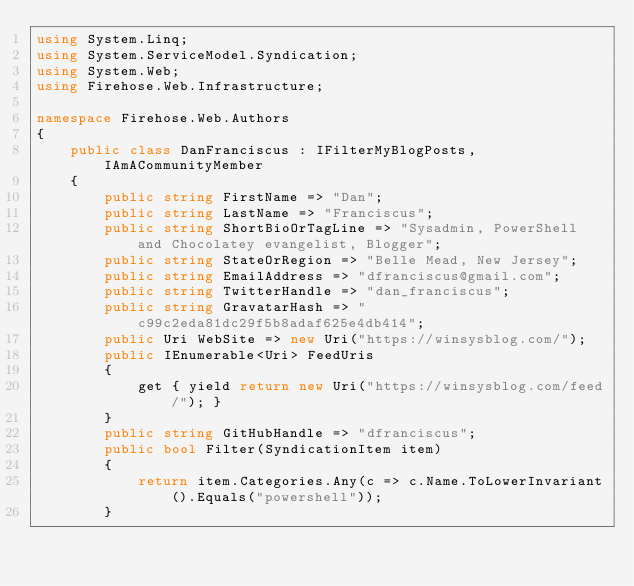Convert code to text. <code><loc_0><loc_0><loc_500><loc_500><_C#_>using System.Linq;
using System.ServiceModel.Syndication;
using System.Web;
using Firehose.Web.Infrastructure;

namespace Firehose.Web.Authors
{
    public class DanFranciscus : IFilterMyBlogPosts, IAmACommunityMember
    {
        public string FirstName => "Dan";
        public string LastName => "Franciscus";
        public string ShortBioOrTagLine => "Sysadmin, PowerShell and Chocolatey evangelist, Blogger";
        public string StateOrRegion => "Belle Mead, New Jersey";
        public string EmailAddress => "dfranciscus@gmail.com";
        public string TwitterHandle => "dan_franciscus";
        public string GravatarHash => "c99c2eda81dc29f5b8adaf625e4db414";
        public Uri WebSite => new Uri("https://winsysblog.com/");
        public IEnumerable<Uri> FeedUris
        {
            get { yield return new Uri("https://winsysblog.com/feed/"); }
        }
        public string GitHubHandle => "dfranciscus";
        public bool Filter(SyndicationItem item)
        {
            return item.Categories.Any(c => c.Name.ToLowerInvariant().Equals("powershell"));
        }</code> 